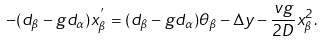<formula> <loc_0><loc_0><loc_500><loc_500>- ( d _ { \beta } - g d _ { \alpha } ) x _ { \beta } ^ { ^ { \prime } } = ( d _ { \beta } - g d _ { \alpha } ) \theta _ { \beta } - \Delta y - \frac { v g } { 2 D } x _ { \beta } ^ { 2 } .</formula> 